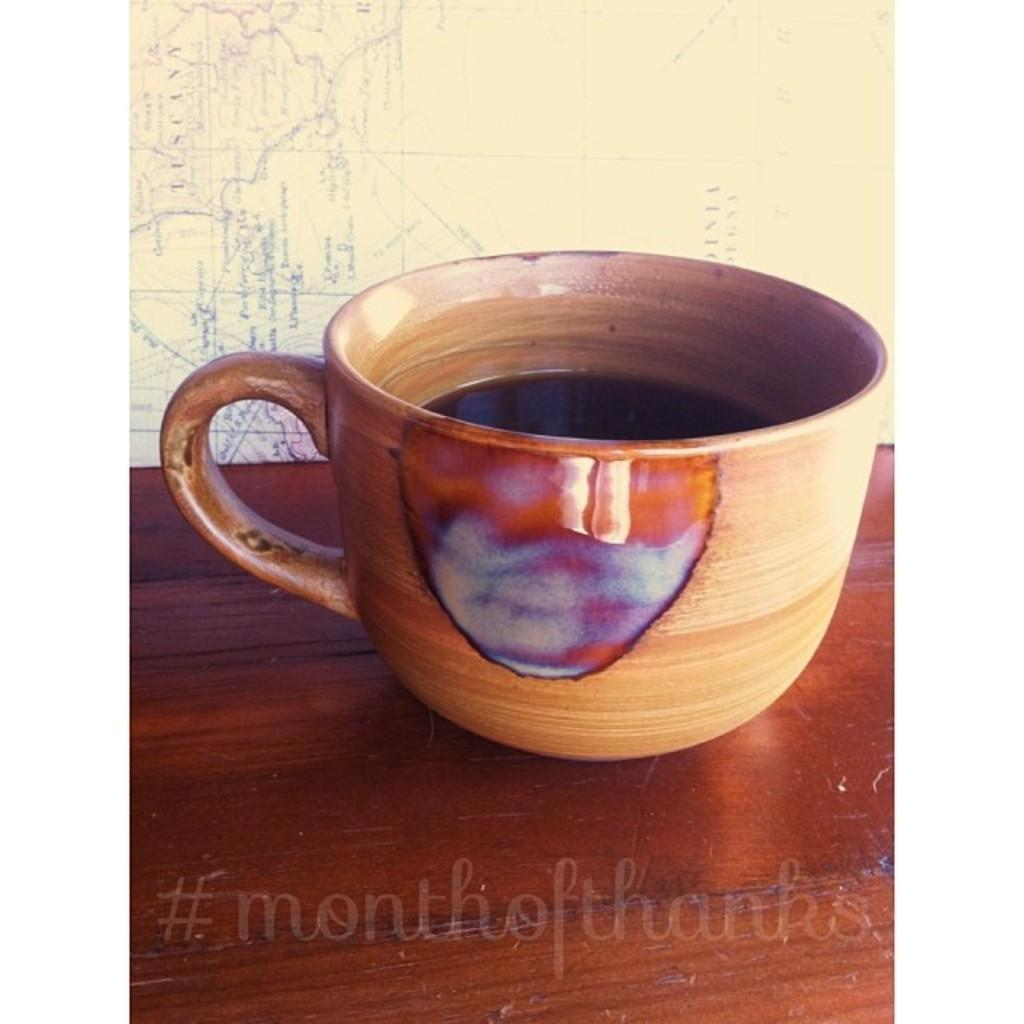What object is placed on the wooden surface in the image? There is a cup on a wooden surface in the image. What can be found at the bottom of the image? There is text at the bottom side of the image. What type of background is visible in the image? There is a map in the background of the image. How many dinosaurs can be seen in the image? There are no dinosaurs present in the image. What is the mass of the thing in the image? The question is unclear as there is no "thing" mentioned in the provided facts. However, the mass of the cup can be estimated based on its size and material, but this information is not available from the facts given. 